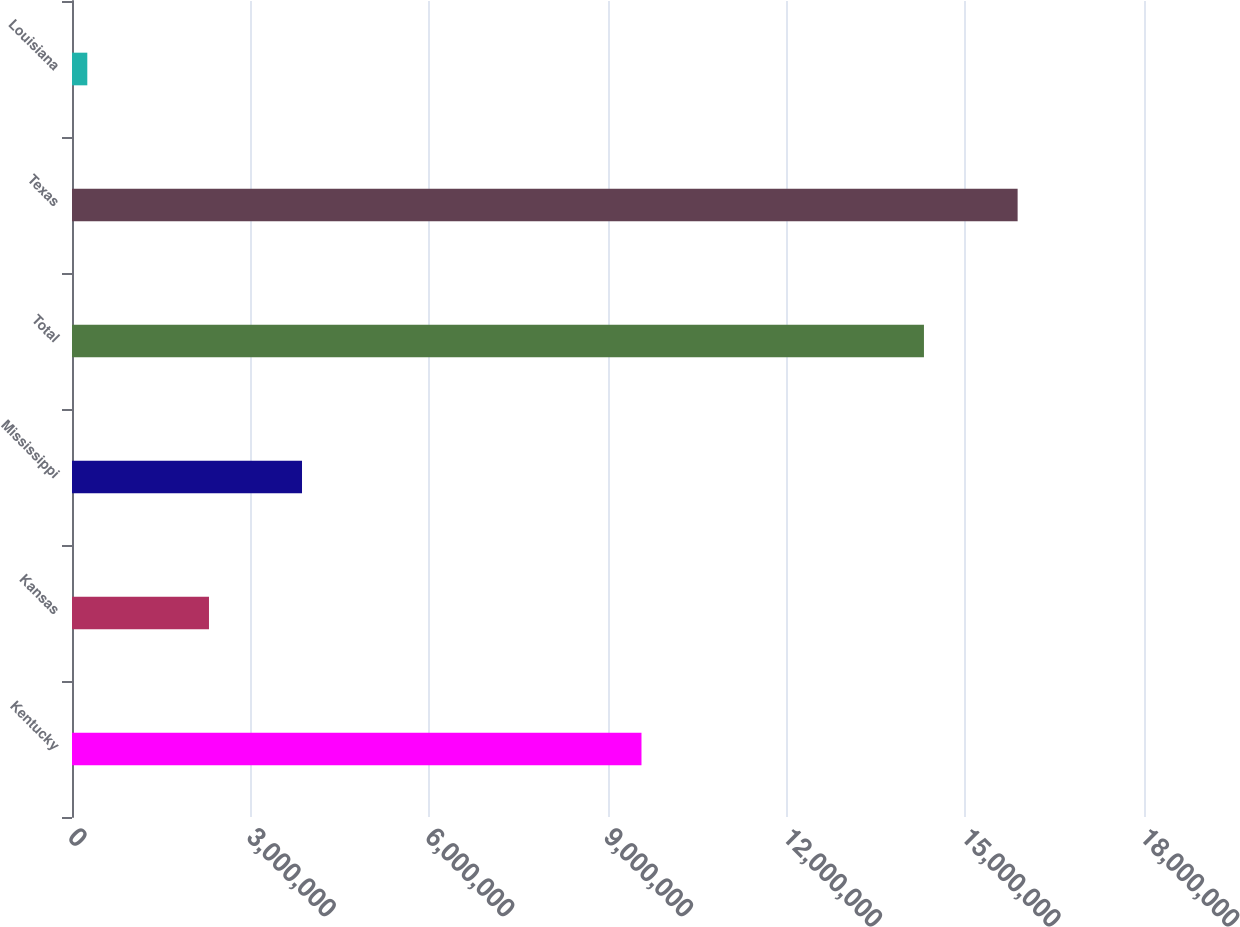<chart> <loc_0><loc_0><loc_500><loc_500><bar_chart><fcel>Kentucky<fcel>Kansas<fcel>Mississippi<fcel>Total<fcel>Texas<fcel>Louisiana<nl><fcel>9.56228e+06<fcel>2.3e+06<fcel>3.86211e+06<fcel>1.43052e+07<fcel>1.5878e+07<fcel>256900<nl></chart> 